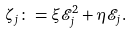Convert formula to latex. <formula><loc_0><loc_0><loc_500><loc_500>\zeta _ { j } \colon = \xi { \mathcal { E } } _ { j } ^ { 2 } + \eta { \mathcal { E } } _ { j } .</formula> 